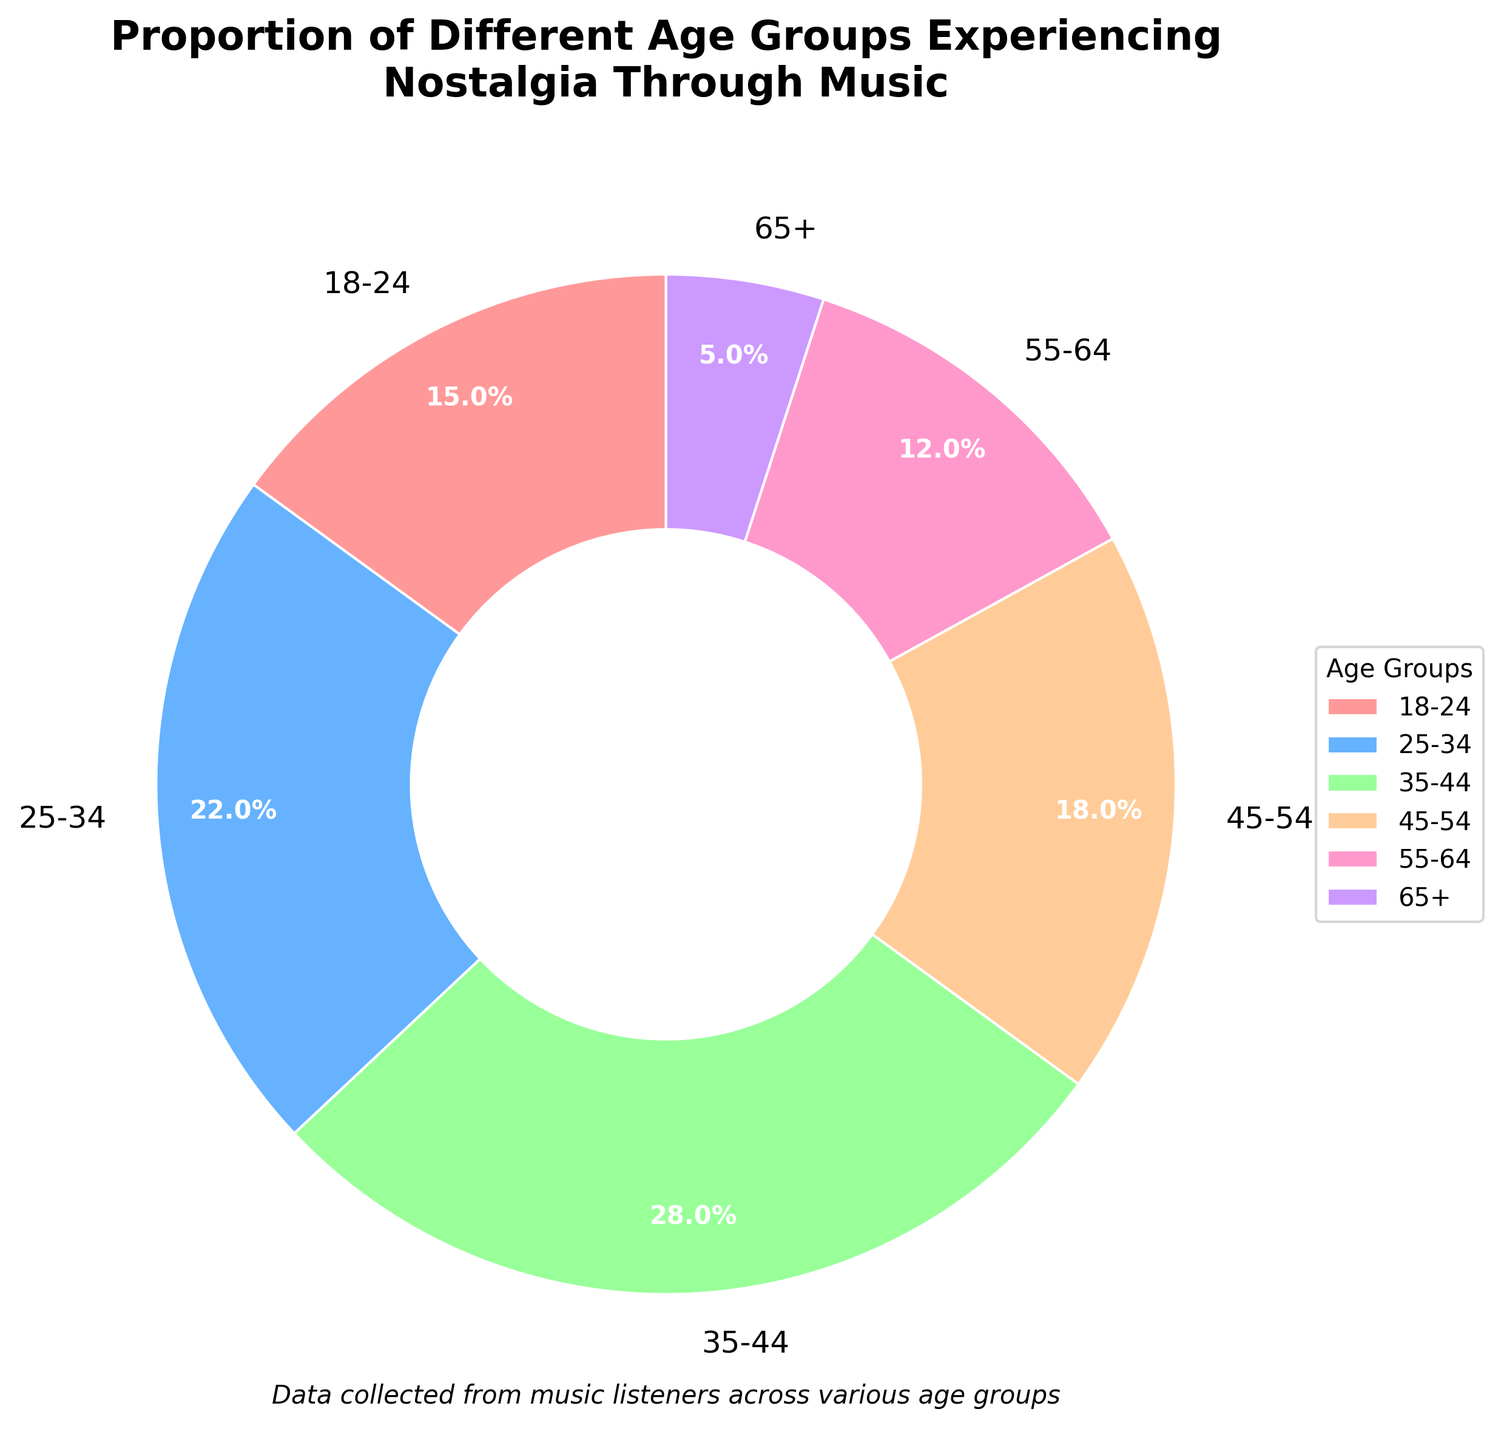Which age group has the largest proportion experiencing nostalgia through music? According to the chart, the age group with the largest proportion is the one with the highest percentage section in the pie chart. The group with the highest percentage is 35-44.
Answer: 35-44 How much larger is the proportion of the 25-34 age group experiencing nostalgia through music compared to the 65+ age group? From the chart, the 25-34 age group has a percentage of 22%, and the 65+ age group has a percentage of 5%. To find the difference, subtract 5% from 22%.
Answer: 17% What is the combined percentage of people aged 45-54 and 55-64 experiencing nostalgia through music? To calculate the combined percentage, add the percentages of the 45-54 age group and the 55-64 age group. This would be 18% + 12%.
Answer: 30% Which age group is represented by the yellow wedge in the pie chart? By visually inspecting the pie chart, trace the color key or labels to identify which age group corresponds to the yellow wedge. The yellow wedge represents the 45-54 age group.
Answer: 45-54 How does the proportion of the 18-24 age group compare to the 55-64 age group? From the chart, the 18-24 age group has a percentage of 15%, and the 55-64 age group has a percentage of 12%. Comparing these, 15% is greater than 12%.
Answer: Greater What is the average percentage of the 18-24, 25-34, and 35-44 age groups experiencing nostalgia through music? To find the average, add the percentages of the 18-24, 25-34, and 35-44 age groups and then divide by 3: (15% + 22% + 28%) / 3.
Answer: 21.67% Which two age groups combined make up more than 50% of the proportion? From the chart, we need to find two age groups whose combined percentages exceed 50%. The 35-44 age group (28%) combined with the 25-34 age group (22%) equals 50%. Since no pair on their own exceeds 50%, we look for any with potential leftover coloring. However, no other pair totals over 50%.
Answer: No pair What is the visual representation of the smallest group in terms of experiencing nostalgia through music? Identify the smallest wedge in the pie chart and match it to the age group. The smallest wedge represents the 65+ age group, given it occupies the least area.
Answer: 65+ What percentage of the total do the three oldest age groups combined (45-54, 55-64, 65+) represent? Sum the percentages of the age groups 45-54, 55-64, and 65+ to find the total representation: 18% + 12% + 5%.
Answer: 35% What portion of the age groups make up less than 20% each? Identify the age groups with percentages below 20% each in the chart. The groups 18-24 (15%), 55-64 (12%), and 65+ (5%) fall below this threshold.
Answer: 18-24, 55-64, 65+ 